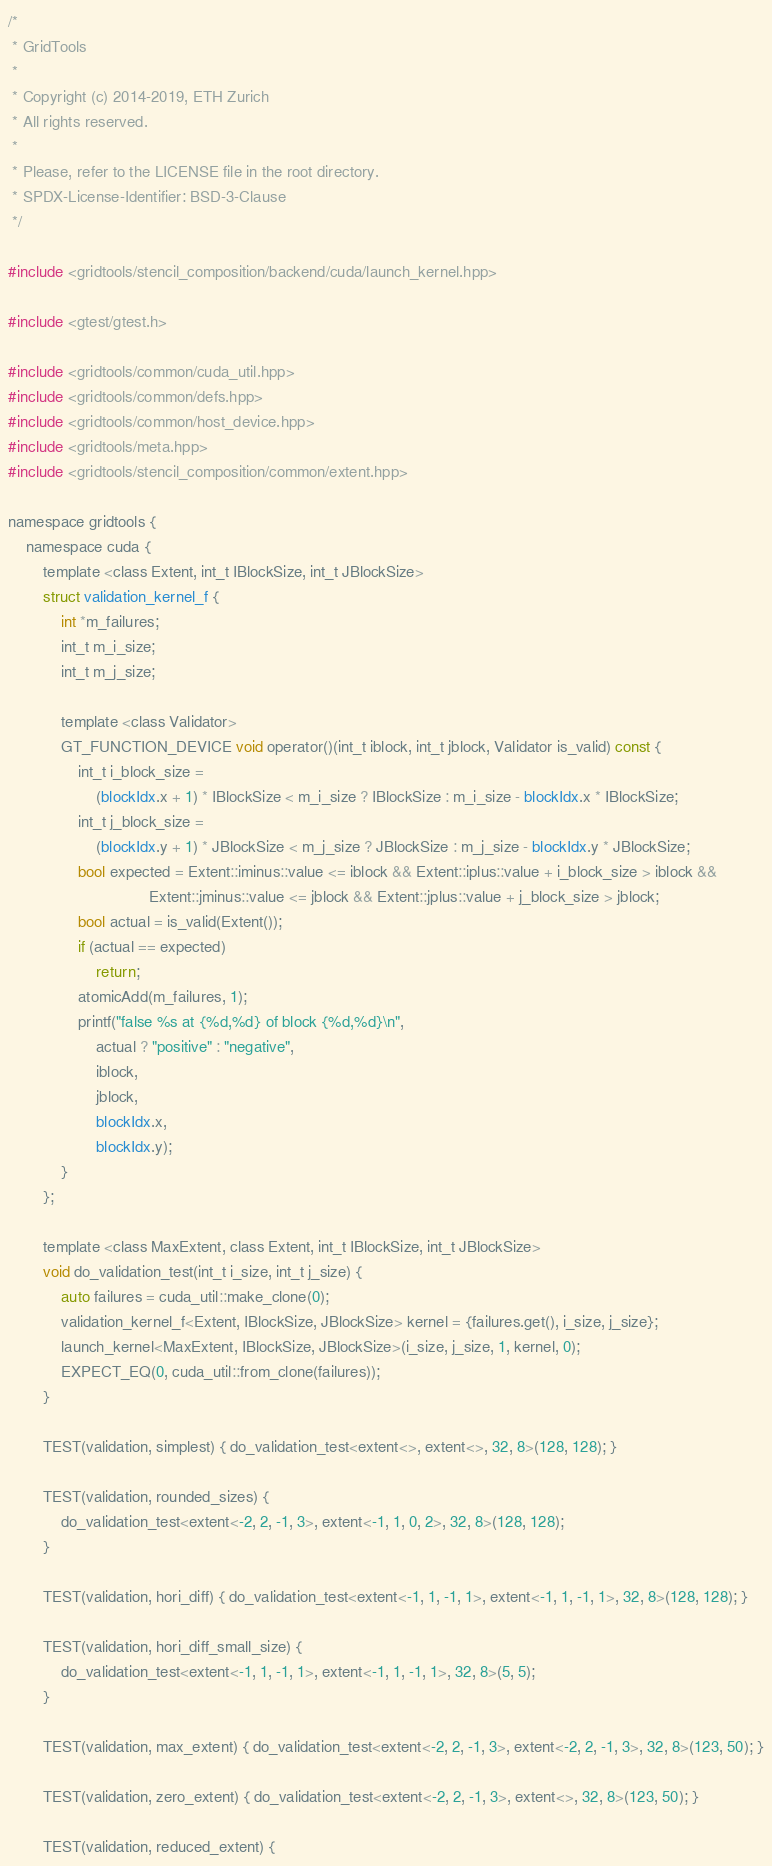Convert code to text. <code><loc_0><loc_0><loc_500><loc_500><_Cuda_>/*
 * GridTools
 *
 * Copyright (c) 2014-2019, ETH Zurich
 * All rights reserved.
 *
 * Please, refer to the LICENSE file in the root directory.
 * SPDX-License-Identifier: BSD-3-Clause
 */

#include <gridtools/stencil_composition/backend/cuda/launch_kernel.hpp>

#include <gtest/gtest.h>

#include <gridtools/common/cuda_util.hpp>
#include <gridtools/common/defs.hpp>
#include <gridtools/common/host_device.hpp>
#include <gridtools/meta.hpp>
#include <gridtools/stencil_composition/common/extent.hpp>

namespace gridtools {
    namespace cuda {
        template <class Extent, int_t IBlockSize, int_t JBlockSize>
        struct validation_kernel_f {
            int *m_failures;
            int_t m_i_size;
            int_t m_j_size;

            template <class Validator>
            GT_FUNCTION_DEVICE void operator()(int_t iblock, int_t jblock, Validator is_valid) const {
                int_t i_block_size =
                    (blockIdx.x + 1) * IBlockSize < m_i_size ? IBlockSize : m_i_size - blockIdx.x * IBlockSize;
                int_t j_block_size =
                    (blockIdx.y + 1) * JBlockSize < m_j_size ? JBlockSize : m_j_size - blockIdx.y * JBlockSize;
                bool expected = Extent::iminus::value <= iblock && Extent::iplus::value + i_block_size > iblock &&
                                Extent::jminus::value <= jblock && Extent::jplus::value + j_block_size > jblock;
                bool actual = is_valid(Extent());
                if (actual == expected)
                    return;
                atomicAdd(m_failures, 1);
                printf("false %s at {%d,%d} of block {%d,%d}\n",
                    actual ? "positive" : "negative",
                    iblock,
                    jblock,
                    blockIdx.x,
                    blockIdx.y);
            }
        };

        template <class MaxExtent, class Extent, int_t IBlockSize, int_t JBlockSize>
        void do_validation_test(int_t i_size, int_t j_size) {
            auto failures = cuda_util::make_clone(0);
            validation_kernel_f<Extent, IBlockSize, JBlockSize> kernel = {failures.get(), i_size, j_size};
            launch_kernel<MaxExtent, IBlockSize, JBlockSize>(i_size, j_size, 1, kernel, 0);
            EXPECT_EQ(0, cuda_util::from_clone(failures));
        }

        TEST(validation, simplest) { do_validation_test<extent<>, extent<>, 32, 8>(128, 128); }

        TEST(validation, rounded_sizes) {
            do_validation_test<extent<-2, 2, -1, 3>, extent<-1, 1, 0, 2>, 32, 8>(128, 128);
        }

        TEST(validation, hori_diff) { do_validation_test<extent<-1, 1, -1, 1>, extent<-1, 1, -1, 1>, 32, 8>(128, 128); }

        TEST(validation, hori_diff_small_size) {
            do_validation_test<extent<-1, 1, -1, 1>, extent<-1, 1, -1, 1>, 32, 8>(5, 5);
        }

        TEST(validation, max_extent) { do_validation_test<extent<-2, 2, -1, 3>, extent<-2, 2, -1, 3>, 32, 8>(123, 50); }

        TEST(validation, zero_extent) { do_validation_test<extent<-2, 2, -1, 3>, extent<>, 32, 8>(123, 50); }

        TEST(validation, reduced_extent) {</code> 